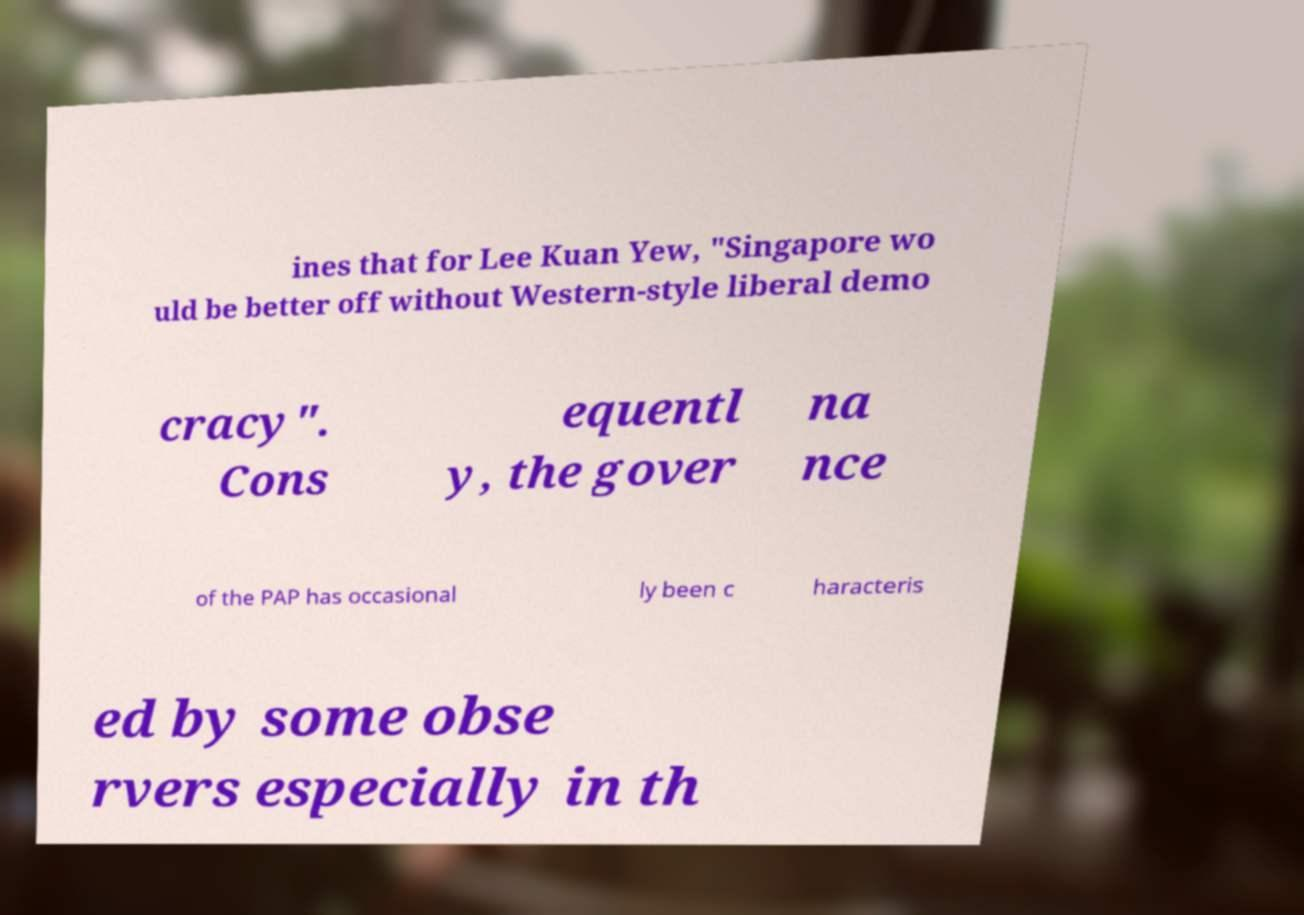For documentation purposes, I need the text within this image transcribed. Could you provide that? ines that for Lee Kuan Yew, "Singapore wo uld be better off without Western-style liberal demo cracy". Cons equentl y, the gover na nce of the PAP has occasional ly been c haracteris ed by some obse rvers especially in th 